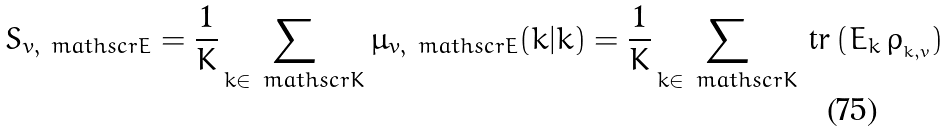<formula> <loc_0><loc_0><loc_500><loc_500>S _ { v , \ m a t h s c r { E } } = \frac { 1 } { K } \sum _ { k \in \ m a t h s c r { K } } \mu _ { v , \ m a t h s c r { E } } ( k | k ) = \frac { 1 } { K } \sum _ { k \in \ m a t h s c r { K } } \, \text {tr} \left ( E _ { k } \, \rho _ { _ { k , v } } \right )</formula> 